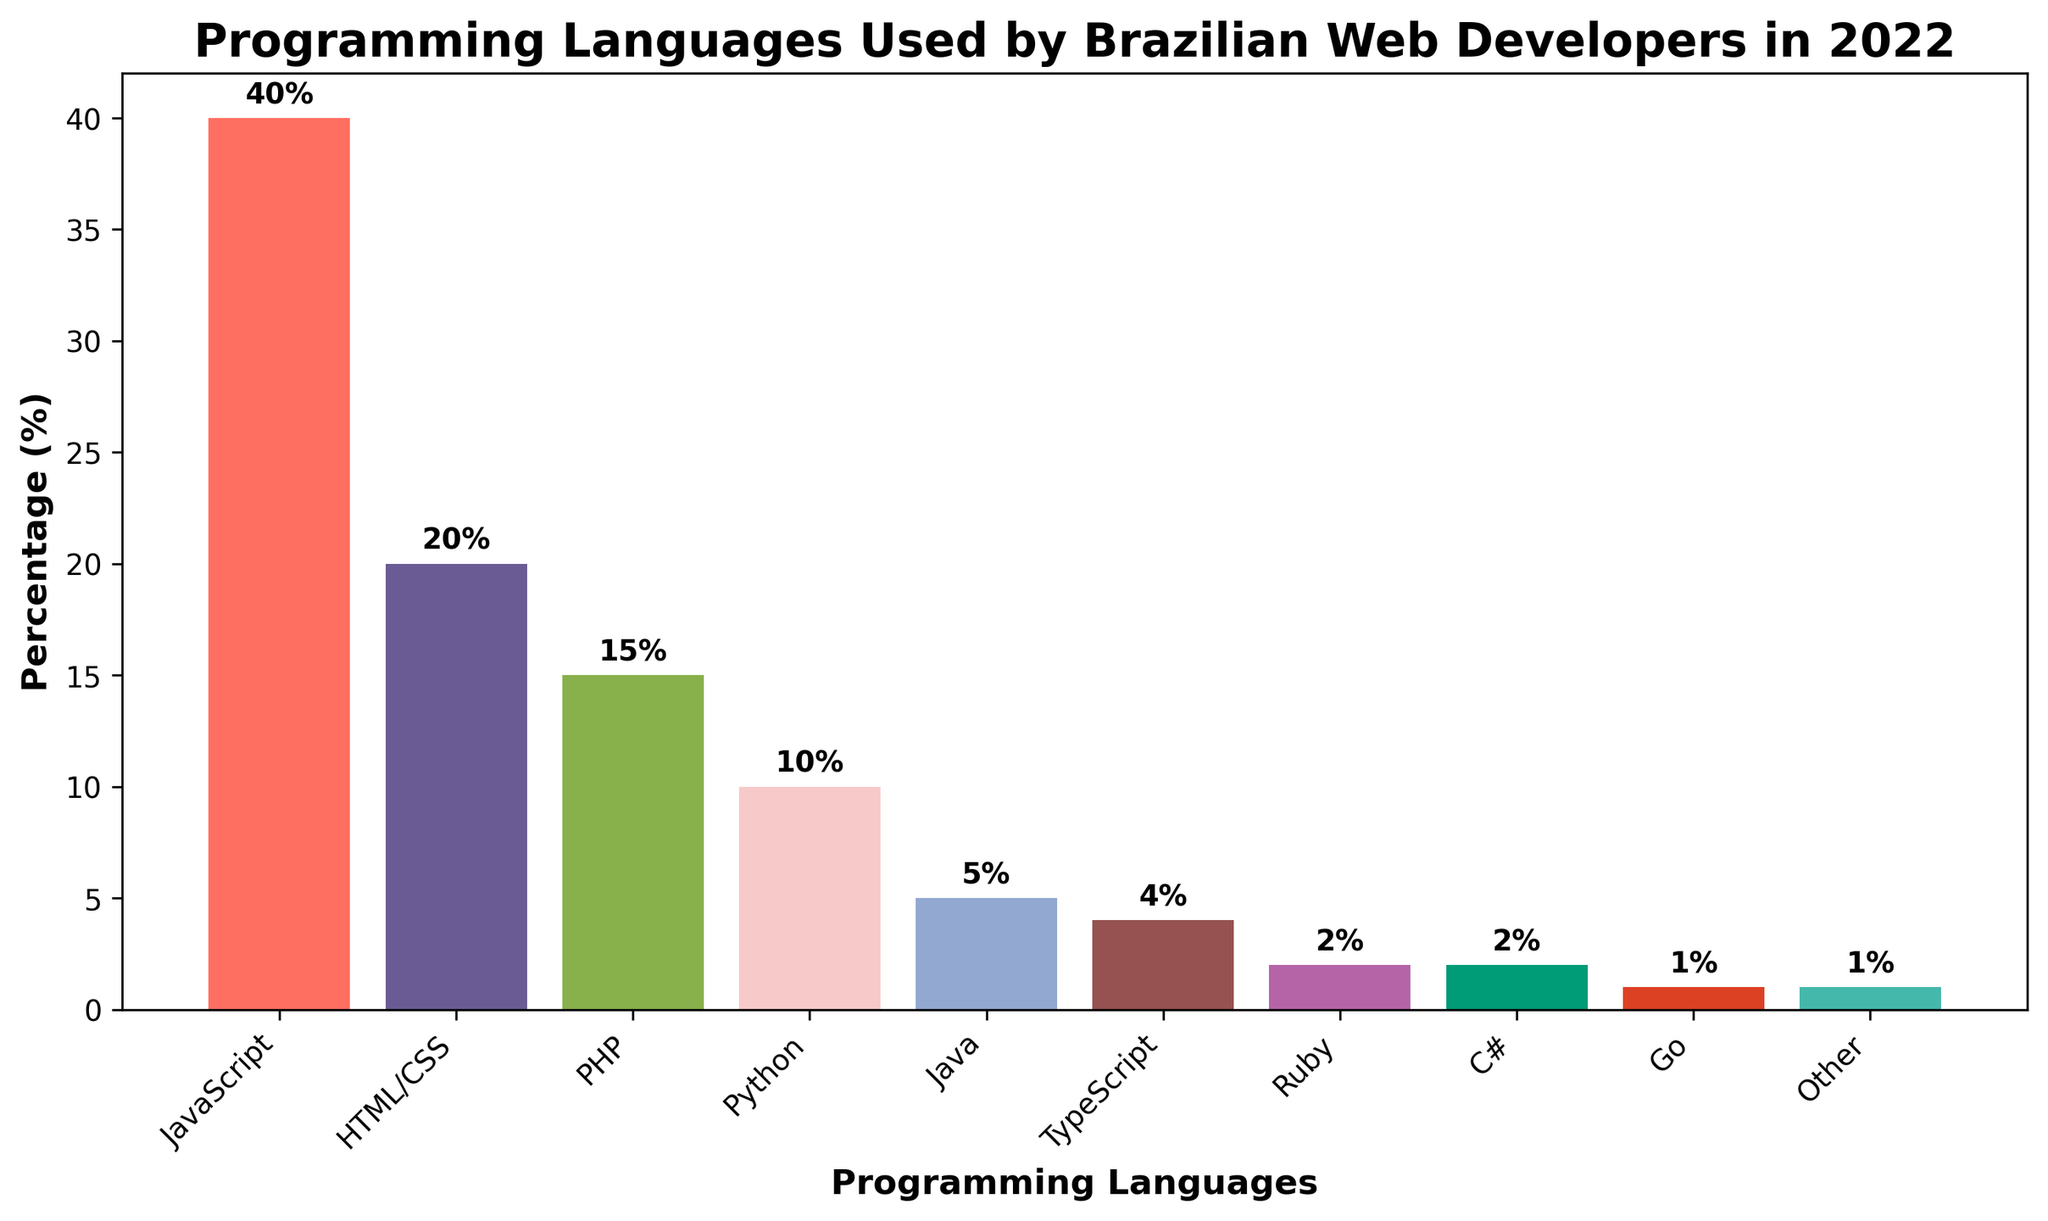How many languages have a usage of less than 5%? By looking at the height values on the y-axis and the bars with percentages less than 5%, we can count the languages. Go (1%), C# (2%), Ruby (2%), TypeScript (4%), and Java (5%) are all less than 5%. Counting them, we find there are 5.
Answer: 5 Which programming language is used by the most Brazilian web developers? We compare the heights of all the bars to find the tallest one. The tallest bar represents JavaScript with 40%.
Answer: JavaScript What percentage of Brazilian web developers use HTML/CSS? Reading the y-value label directly from the bar for HTML/CSS, we see it is 20%.
Answer: 20% What is the combined usage percentage of PHP and Python? Adding the percentages of PHP (15%) and Python (10%), we get a total of 15 + 10 = 25%.
Answer: 25% Is TypeScript used more or less than Ruby among Brazilian web developers? Comparing the heights of the bars for TypeScript (4%) and Ruby (2%), we see that the bar for TypeScript is taller. Therefore, TypeScript is used more than Ruby.
Answer: More How much more popular is JavaScript compared to Java? Subtract the percentage for Java (5%) from JavaScript (40%) to get 40 - 5 = 35%.
Answer: 35% Which programming languages are represented by bars with similar heights? The bars for Ruby (2%) and C# (2%) have similar heights. Additionally, the bars for TypeScript (4%) and a half height of HTML/CSS (20%) represent relationships.
Answer: Ruby and C# Among the languages with less than 10% usage, which one is the highest? We identify the languages below 10% usage: Python (10%), Java (5%), TypeScript (4%), Ruby (2%), C# (2%), Go (1%), and Other (1%). Python is right at the 10% mark but not below it, so Java is the highest with 5%.
Answer: Java How does the height of the bar for HTML/CSS compare to that of PHP? The bar for HTML/CSS (20%) is taller than the bar for PHP (15%).
Answer: Taller If you sum the percentages of languages used by fewer than 5% of developers, what is the total? Adding the percentages for TypeScript (4%), Ruby (2%), C# (2%), Go (1%), and Other (1%): 4 + 2 + 2 + 1 + 1 = 10%.
Answer: 10 